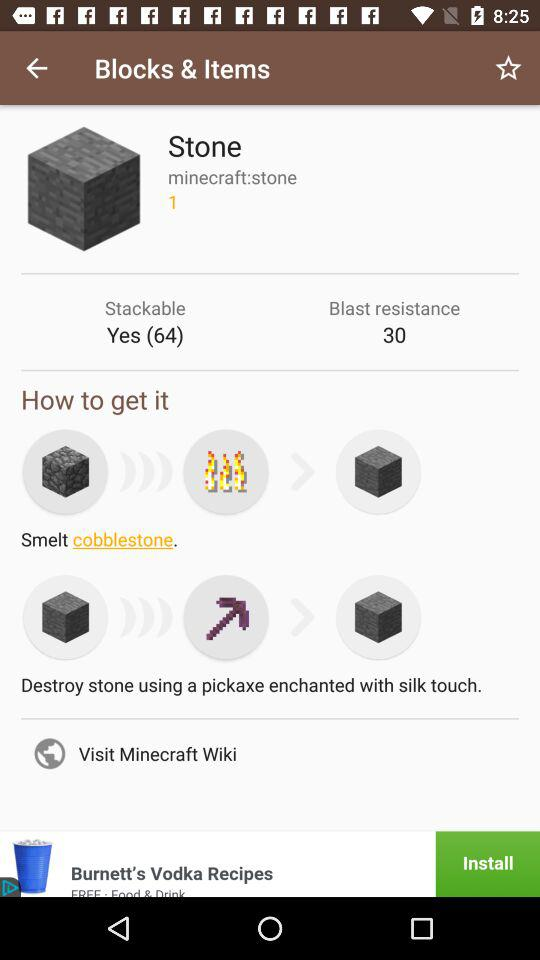What is the user's name?
When the provided information is insufficient, respond with <no answer>. <no answer> 